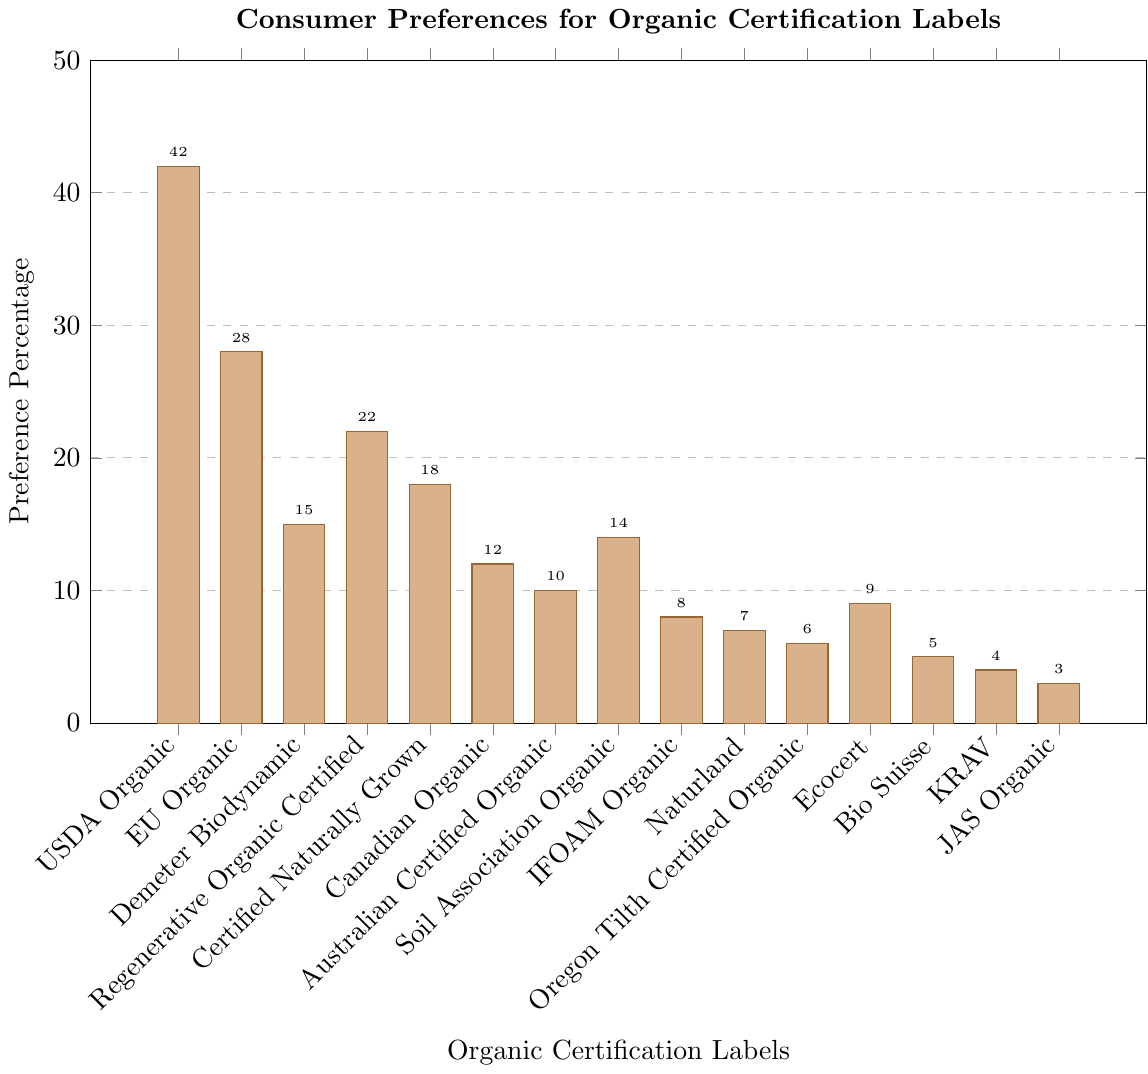Which organic certification label has the highest consumer preference percentage? By looking at the heights of the bars in the bar chart, identify which bar is the tallest. The tallest bar represents the USDA Organic label, which has a preference percentage of 42%.
Answer: USDA Organic Which organic certification labels have a consumer preference percentage of less than 10%? Examine the heights of the bars and look for those that do not reach the 10% mark. The labels are IFOAM Organic, Naturland, Oregon Tilth Certified Organic, Bio Suisse, KRAV, and JAS Organic.
Answer: IFOAM Organic, Naturland, Oregon Tilth Certified Organic, Bio Suisse, KRAV, JAS Organic What is the combined consumer preference percentage of the three least favored organic certification labels? Identify the three smallest bars and note their values: JAS Organic (3%), KRAV (4%), and Bio Suisse (5%). Add these together to find the combined percentage: 3% + 4% + 5% = 12%.
Answer: 12% Which organic certification labels have a preference percentage higher than the average of all labels? First, calculate the average preference percentage: sum all percentages and then divide by the number of labels. Then compare each percentage to this average. The labels higher than the average are USDA Organic, EU Organic, Demeter Biodynamic, Regenerative Organic Certified, and Certified Naturally Grown.
Answer: USDA Organic, EU Organic, Demeter Biodynamic, Regenerative Organic Certified, Certified Naturally Grown How much higher is the consumer preference percentage for the USDA Organic label compared to the EU Organic label? Determine the percentages for USDA Organic (42%) and EU Organic (28%). Subtract the EU Organic percentage from the USDA Organic percentage: 42% - 28% = 14%.
Answer: 14% Which label has the closest consumer preference percentage to the Soil Association Organic label? Look at the preference percentage for Soil Association Organic (14%) and compare it to other labels' percentages to identify the closest value. Certified Naturally Grown has an 18% preference, so it's the closest.
Answer: Certified Naturally Grown What is the difference in consumer preference percentage between the highest and lowest organic certification labels? Identify the highest (USDA Organic at 42%) and the lowest (JAS Organic at 3%) percentages. Subtract the lowest from the highest preference percentage: 42% - 3% = 39%.
Answer: 39% Which labels have a consumer preference percentage greater than 20% but less than 30%? Examine the bars between the 20% and 30% marks. The labels falling within this range are EU Organic (28%) and Regenerative Organic Certified (22%).
Answer: EU Organic, Regenerative Organic Certified What is the total consumer preference percentage for labels that have a value greater than 15%? Identify the labels with percentages greater than 15%: USDA Organic (42%), EU Organic (28%), Demeter Biodynamic (15%), Regenerative Organic Certified (22%), and Certified Naturally Grown (18%). Add these together: 42% + 28% + 22% + 18% = 110%.
Answer: 110% How many labels have a consumer preference percentage between 5% and 15% inclusive? Identify the labels with percentages in the 5% to 15% range: Demeter Biodynamic (15%), Certified Naturally Grown (18%), Soil Association Organic (14%), Ecocert (9%), and Bio Suisse (5%). Count these labels: there are 5.
Answer: 5 